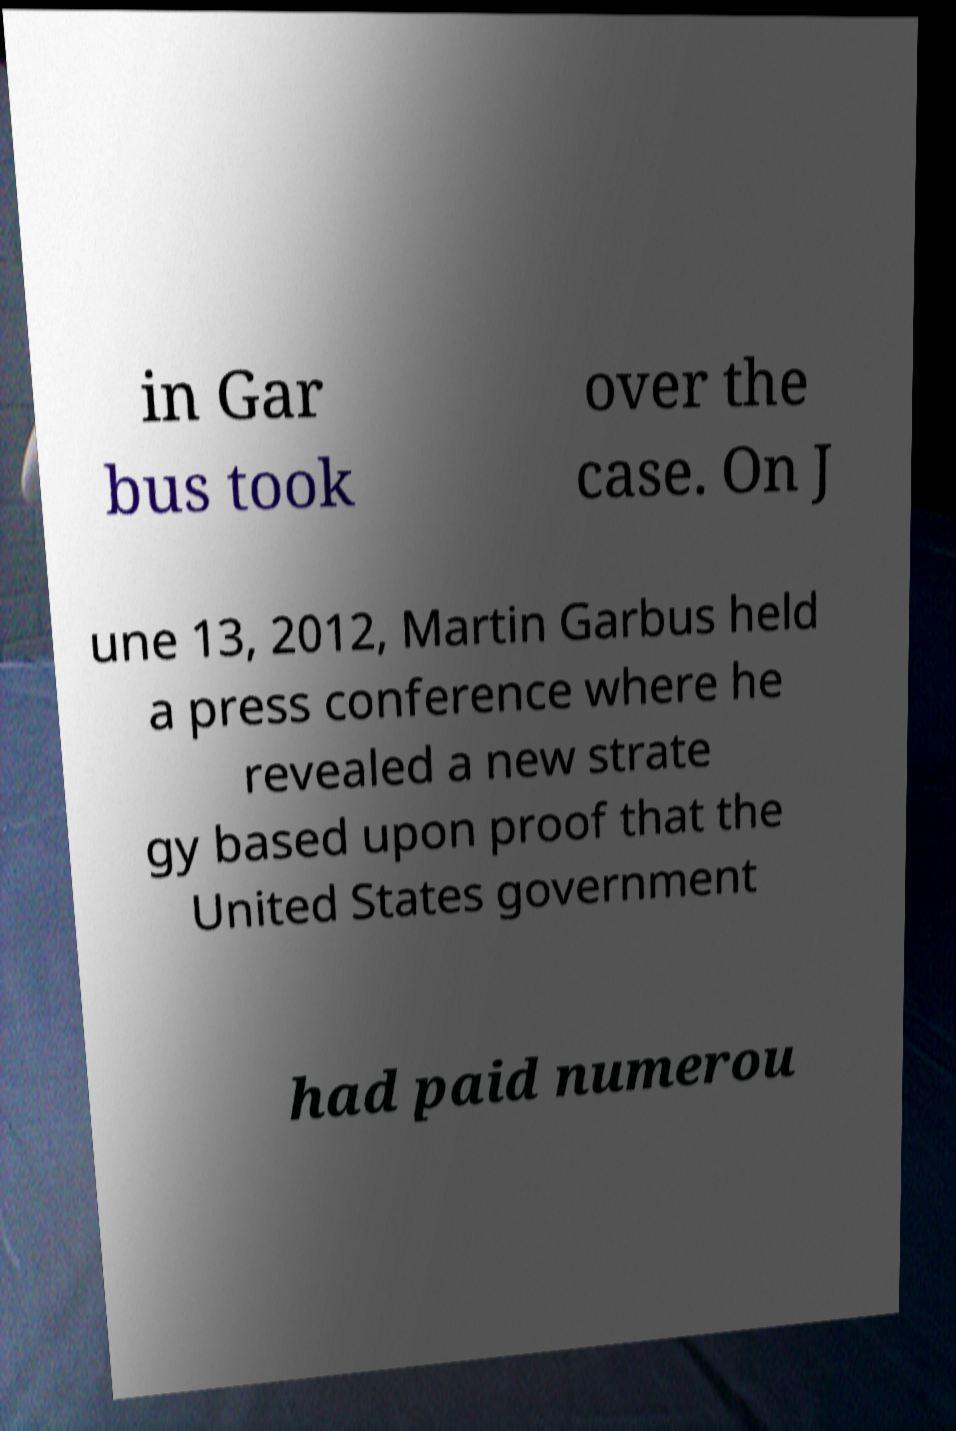Can you accurately transcribe the text from the provided image for me? in Gar bus took over the case. On J une 13, 2012, Martin Garbus held a press conference where he revealed a new strate gy based upon proof that the United States government had paid numerou 